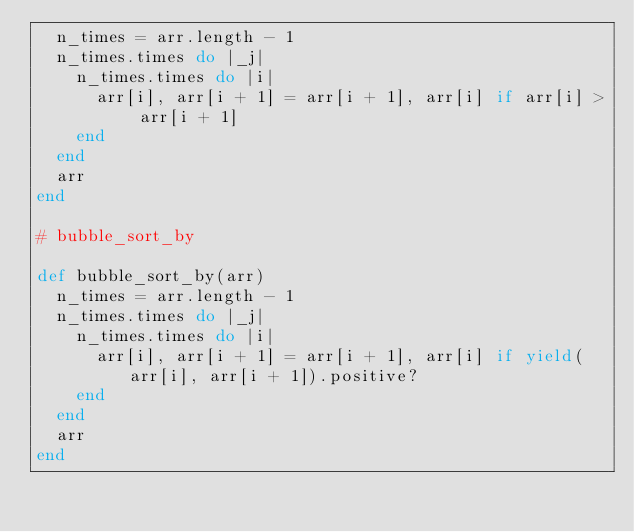<code> <loc_0><loc_0><loc_500><loc_500><_Ruby_>  n_times = arr.length - 1
  n_times.times do |_j|
    n_times.times do |i|
      arr[i], arr[i + 1] = arr[i + 1], arr[i] if arr[i] > arr[i + 1]
    end
  end
  arr
end

# bubble_sort_by

def bubble_sort_by(arr)
  n_times = arr.length - 1
  n_times.times do |_j|
    n_times.times do |i|
      arr[i], arr[i + 1] = arr[i + 1], arr[i] if yield(arr[i], arr[i + 1]).positive?
    end
  end
  arr
end
</code> 